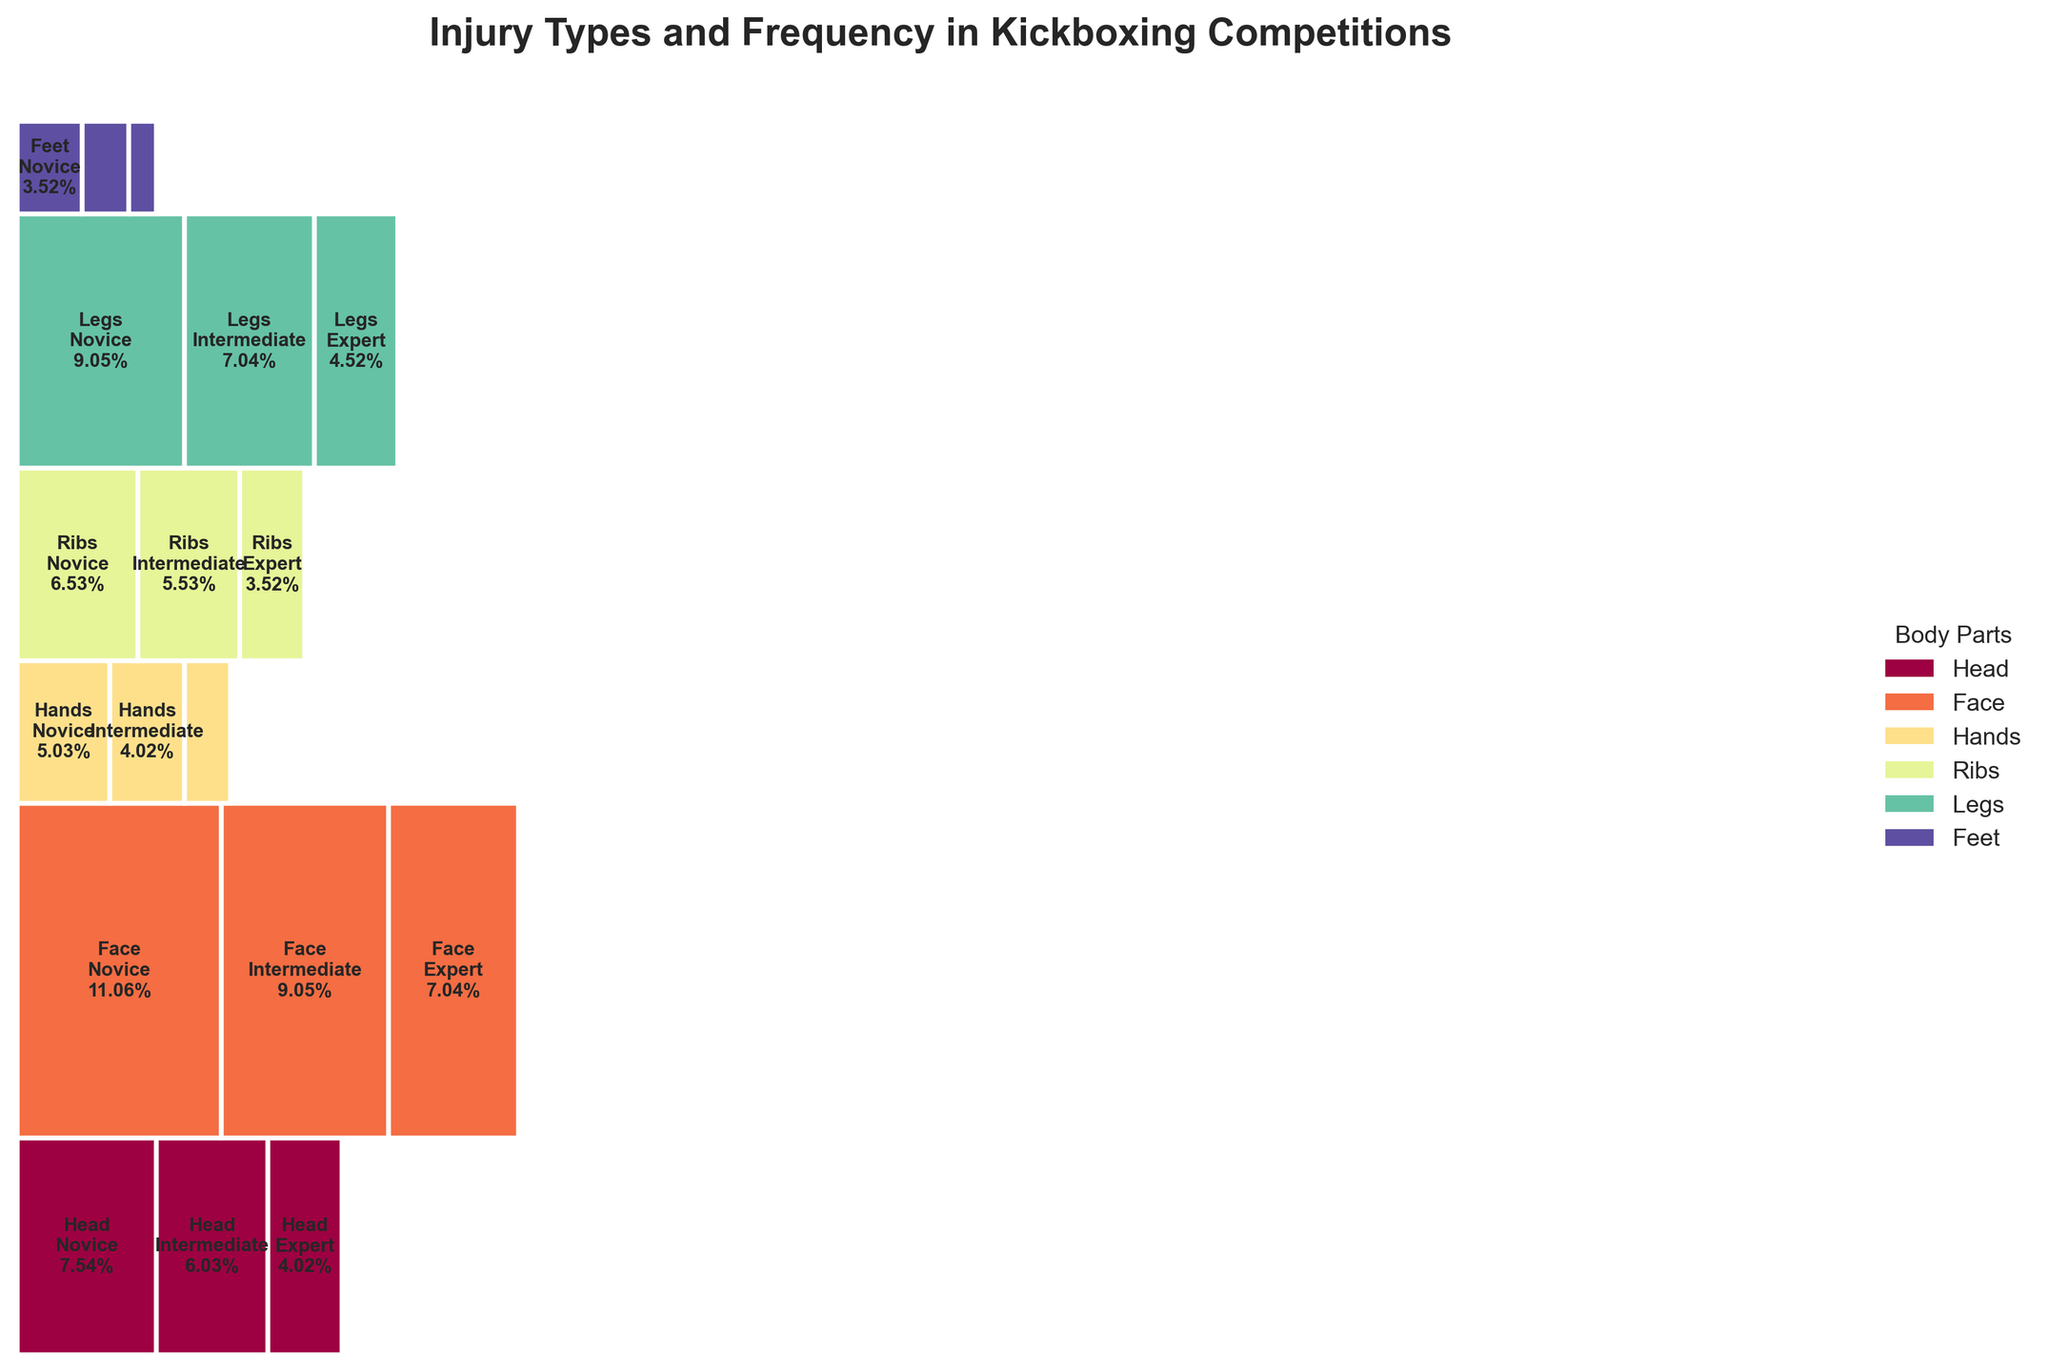What is the title of the mosaic plot? The title of the mosaic plot is usually found at the top of the plot and is often larger and bold compared to other text. The title should give a quick summary of what the plot represents.
Answer: Injury Types and Frequency in Kickboxing Competitions Which body part has the most injuries at the novice level? To determine this, look at the segments labeled "Novice" and compare the proportions for each body part. The largest segment indicates the body part with the most injuries at the novice level.
Answer: Face What is the injury type most frequently affecting experts? The height of the rectangles within each body part will show the injury type and its relative frequency. For experts, examine each body part and note the injury type with the highest frequency.
Answer: Cuts Compare the frequency of hand injuries between novice and intermediate levels. Which one is higher? Find and compare the segments for "Hands" at the "Novice" and "Intermediate" experience levels to see which has a larger proportion.
Answer: Novice Among the given body parts, which one shows the smallest frequency of injuries? To find this, compare all the segments across different body parts and experience levels. The body part with the smallest combined segments represents the least frequent injuries.
Answer: Feet Is the frequency of rib contingencies higher in intermediate or expert levels? Focus on the segments labeled "Ribs" and compare the area sizes for "Intermediate" and "Expert" levels. A larger area indicates higher frequency.
Answer: Intermediate What is the total frequency of leg sprains for all experience levels combined? Sum up the frequencies of leg sprains at novice, intermediate, and expert levels (18 + 14 + 9). This requires basic addition.
Answer: 41 Which body part sees a decrease in injury frequency as experience level increases? Track each body part across the novice, intermediate, and expert levels. A decreasing trend across these levels indicates a decreasing frequency of injuries.
Answer: All body parts (Head, Face, Hands, Ribs, Legs, Feet) show a decrease as experience increases How does the frequency of head concussions compare between novices and experts? Compare the segments labeled "Head" for "Novice" and "Expert." The larger area corresponds to the higher frequency.
Answer: Higher in novices Which body part and experience level combination has the highest frequency of injuries? Identify the largest segment within the mosaic plot. This segment shows the highest frequency of injuries for a particular body part and experience level.
Answer: Face - Novice 